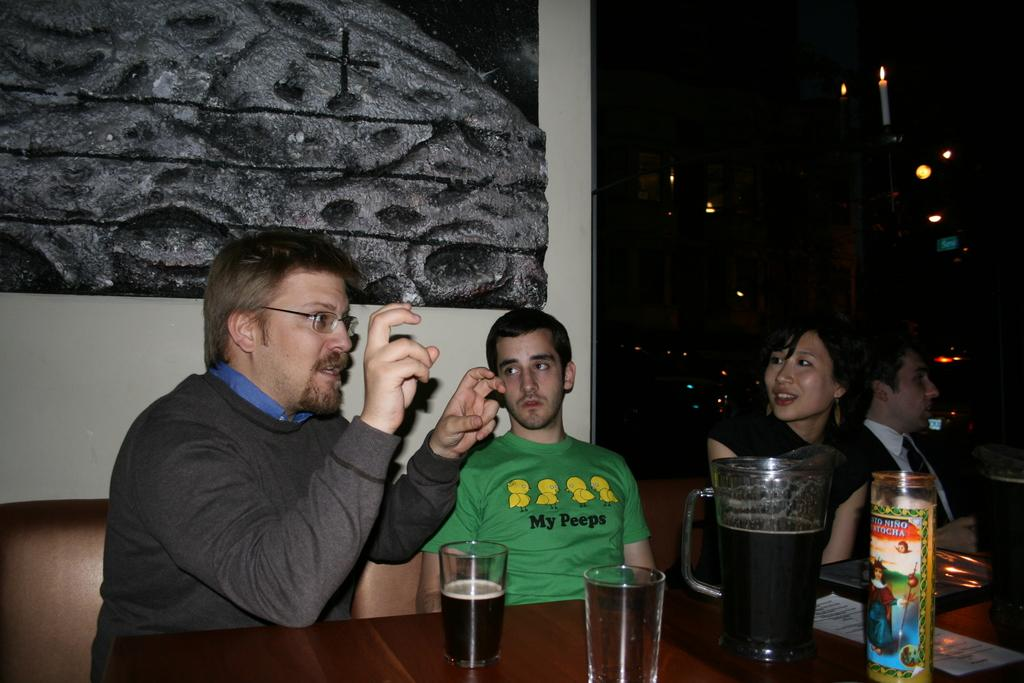<image>
Give a short and clear explanation of the subsequent image. A group of people sit at a table and someone is wearing a green shirt that says "My Peeps". 